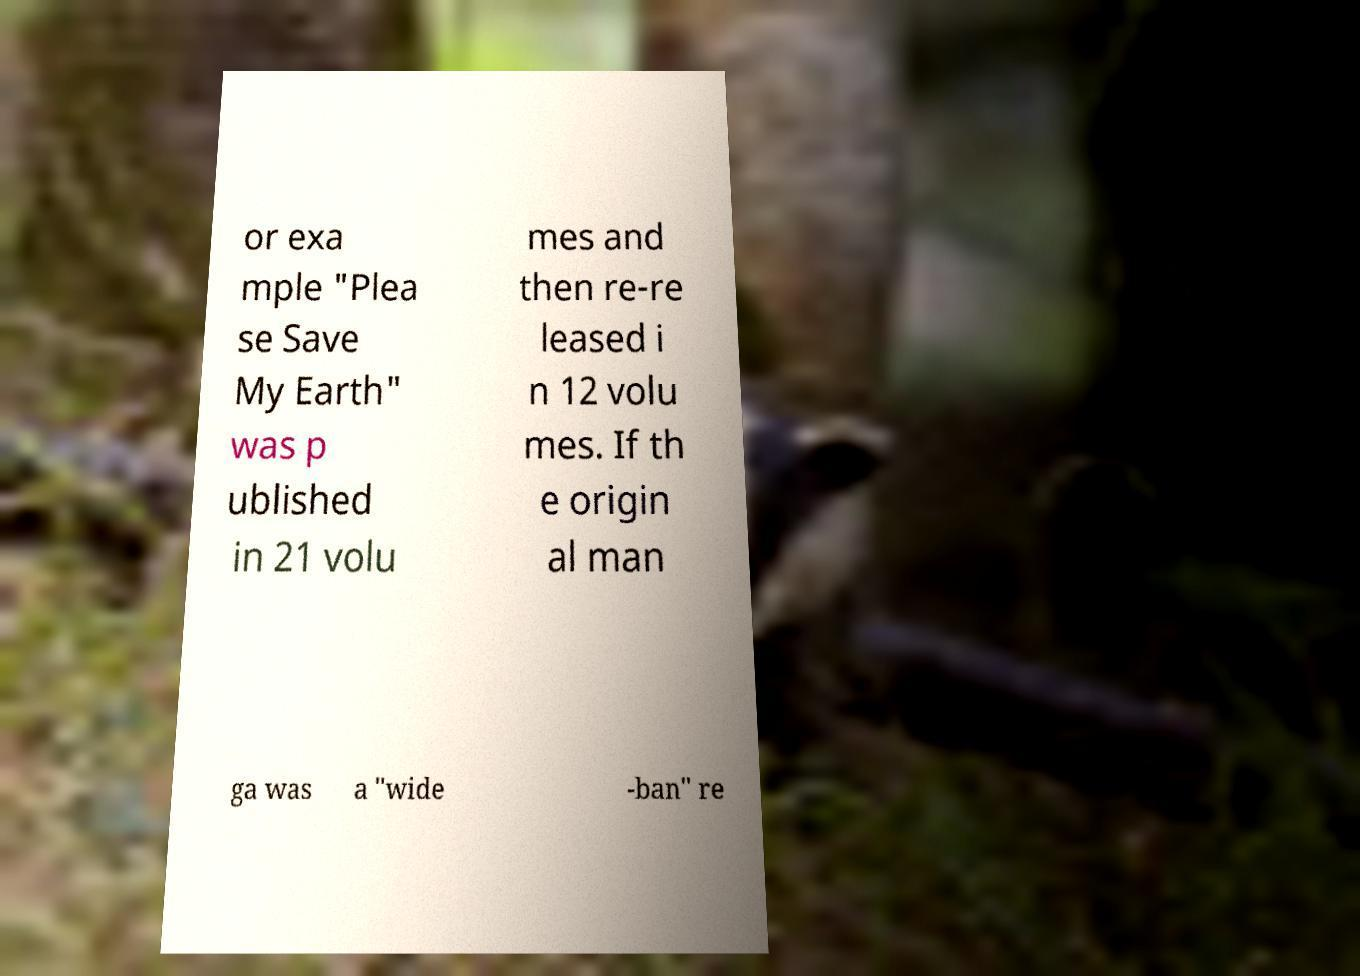I need the written content from this picture converted into text. Can you do that? or exa mple "Plea se Save My Earth" was p ublished in 21 volu mes and then re-re leased i n 12 volu mes. If th e origin al man ga was a "wide -ban" re 